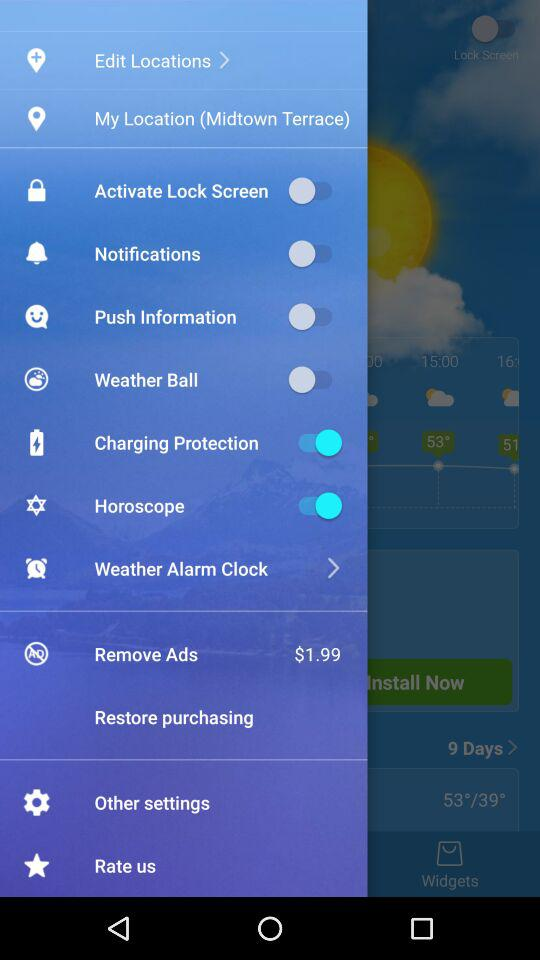What is the status of the "Horoscope"? The status is "on". 